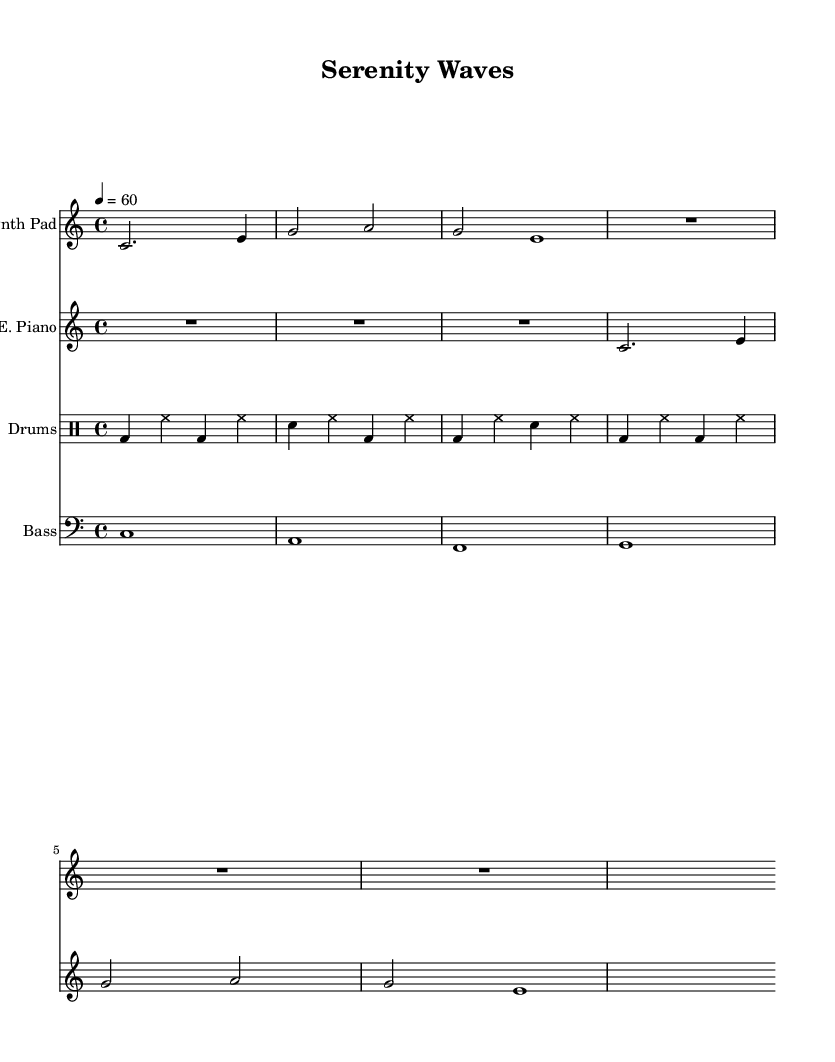What is the key signature of this music? The key signature is C major, which is indicated by the absence of sharps or flats in the key signature section of the music.
Answer: C major What is the time signature of this music? The time signature is 4/4, which is shown at the beginning of the sheet music. This means there are four beats per measure, and the quarter note gets one beat.
Answer: 4/4 What is the tempo marking for this piece? The tempo marking is indicated as 4 = 60, meaning that there are 60 beats per minute with quarter notes, which dictates the speed of the music.
Answer: 60 How many measures are in the Synth Pad section? The Synth Pad section consists of 5 measures as counted from the beginning to the end of the given musical notation.
Answer: 5 What is the primary instrument used in this sheet music? The primary instrument, referenced as the first staff, is the Synth Pad, contributing to the ambient sound evident in this electronic piece.
Answer: Synth Pad What kind of rhythm does the drum machine follow? The drum machine follows a consistent rhythm with a pattern of bass drum and snare mixed with hi-hat, which creates a steady yet relaxing groove suitable for meditation and stress relief.
Answer: Steady rhythm What is the bass note played in the first measure? The bass note in the first measure is C, as indicated in the bass synth staff notation, which establishes the foundational tone of the piece.
Answer: C 